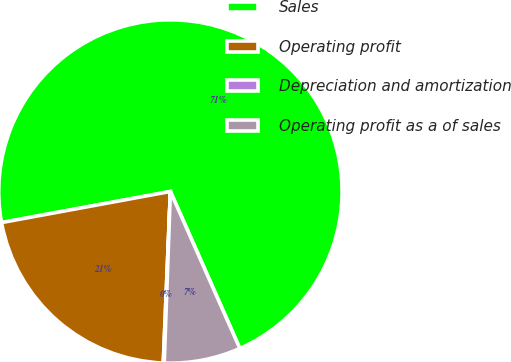Convert chart. <chart><loc_0><loc_0><loc_500><loc_500><pie_chart><fcel>Sales<fcel>Operating profit<fcel>Depreciation and amortization<fcel>Operating profit as a of sales<nl><fcel>71.27%<fcel>21.44%<fcel>0.09%<fcel>7.2%<nl></chart> 